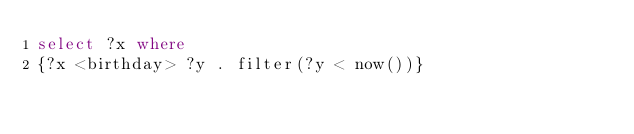Convert code to text. <code><loc_0><loc_0><loc_500><loc_500><_SQL_>select ?x where
{?x <birthday> ?y . filter(?y < now())}</code> 